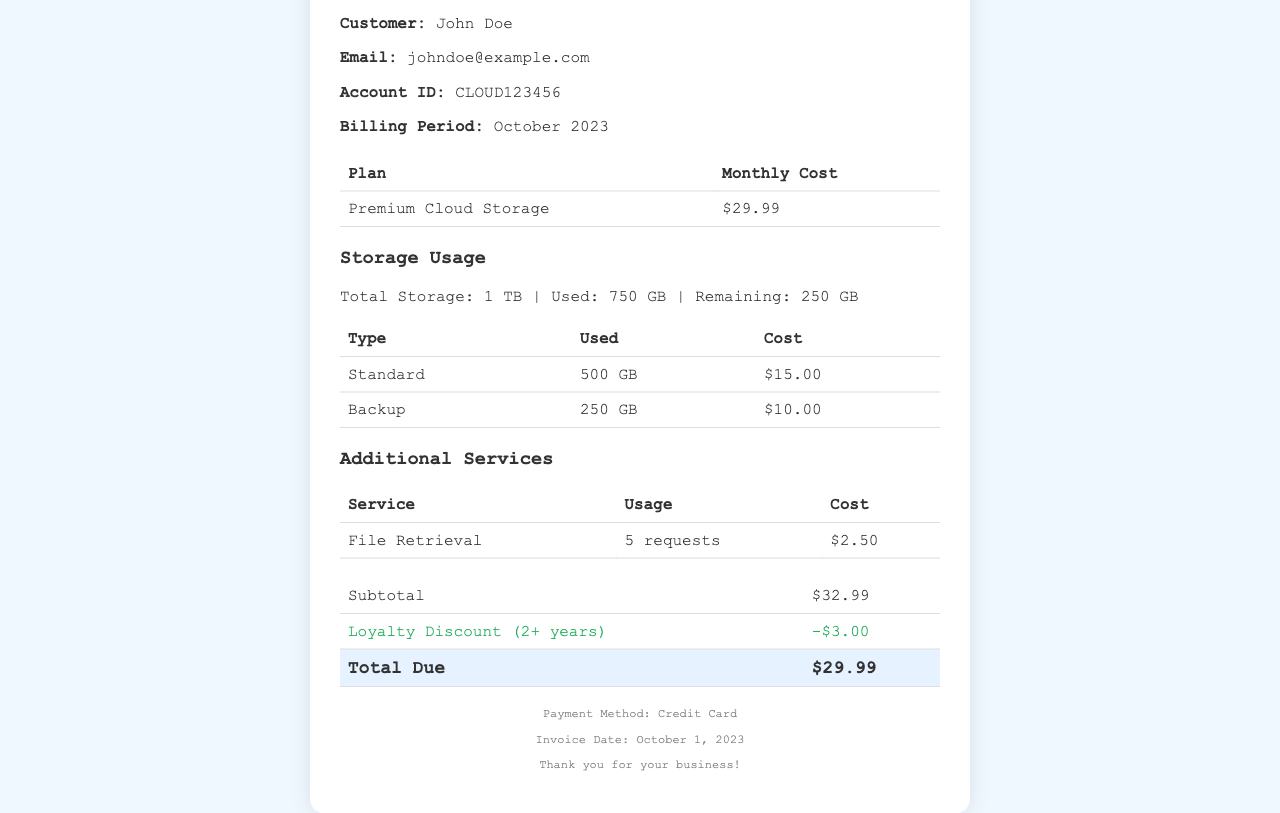What is the customer name? The customer name is explicitly mentioned in the document under customer info.
Answer: John Doe What is the total used storage? The document specifies the total storage used under the storage usage section.
Answer: 750 GB What is the loyalty discount applied? The loyalty discount is shown in the total info section as a deduction from the subtotal.
Answer: -$3.00 How many requests were made for file retrieval? This information is provided under the additional services section, which details service usage.
Answer: 5 requests What is the total due amount? The total due amount is indicated clearly in the total info section of the receipt.
Answer: $29.99 What is the plan type for the subscription? The plan type is listed in the subscription info section detailing the monthly subscription.
Answer: Premium Cloud Storage What is the billing period for this receipt? The billing period is mentioned explicitly in the customer info section.
Answer: October 2023 What was the invoice date? The invoice date is indicated in the footer of the document.
Answer: October 1, 2023 